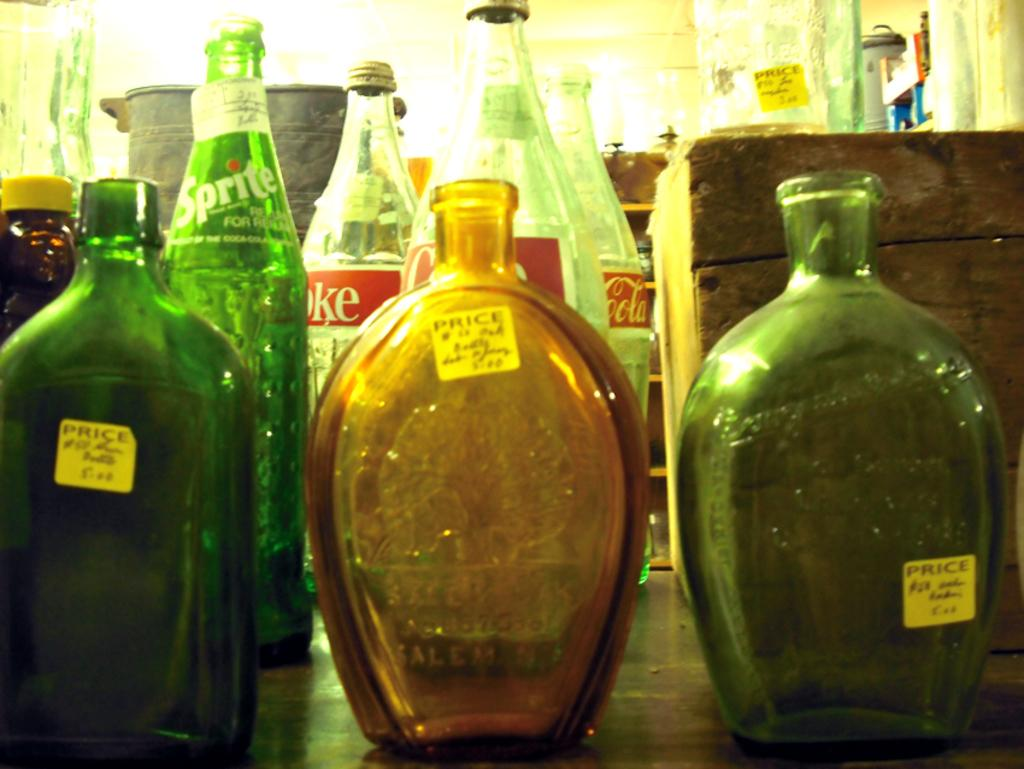Provide a one-sentence caption for the provided image. Several bottles with stickers that say price on them. 